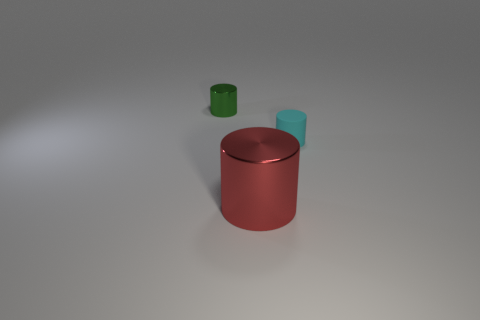Is the size of the red shiny thing the same as the cylinder on the left side of the red shiny object?
Provide a short and direct response. No. Are there more small cyan things than things?
Give a very brief answer. No. Does the cylinder that is on the left side of the red metal object have the same material as the red object to the right of the green cylinder?
Make the answer very short. Yes. What material is the small green object?
Make the answer very short. Metal. Is the number of big red cylinders left of the cyan thing greater than the number of large red matte cylinders?
Keep it short and to the point. Yes. How many big metal cylinders are on the left side of the tiny object right of the shiny object that is behind the small rubber object?
Provide a succinct answer. 1. What is the cylinder that is right of the green thing and left of the cyan cylinder made of?
Offer a terse response. Metal. The large object is what color?
Make the answer very short. Red. Is the number of cylinders behind the tiny cyan cylinder greater than the number of green metallic cylinders that are to the left of the small green metal cylinder?
Give a very brief answer. Yes. There is a metal thing that is behind the cyan thing; what is its color?
Provide a short and direct response. Green. 